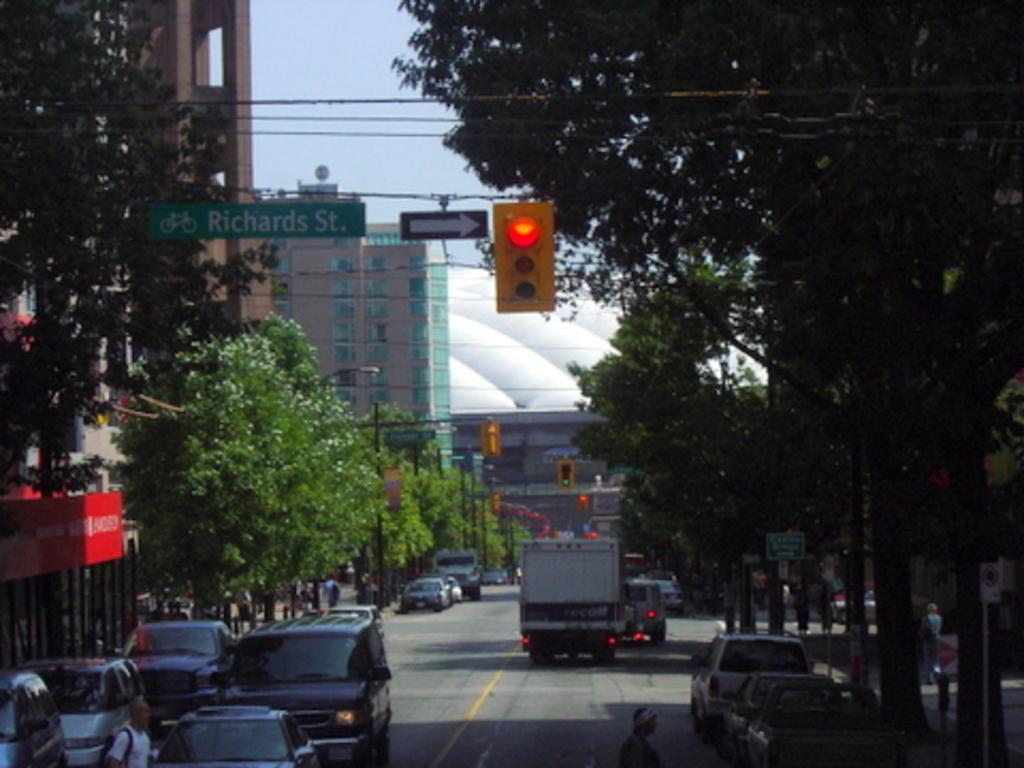Can you describe this image briefly? In the foreground I can see fleets of vehicles on the road, fence, trees, boards, buildings, light poles, bridge and a crowd on the road. In the background I can see the sky and wires. This image is taken may be on the road. 